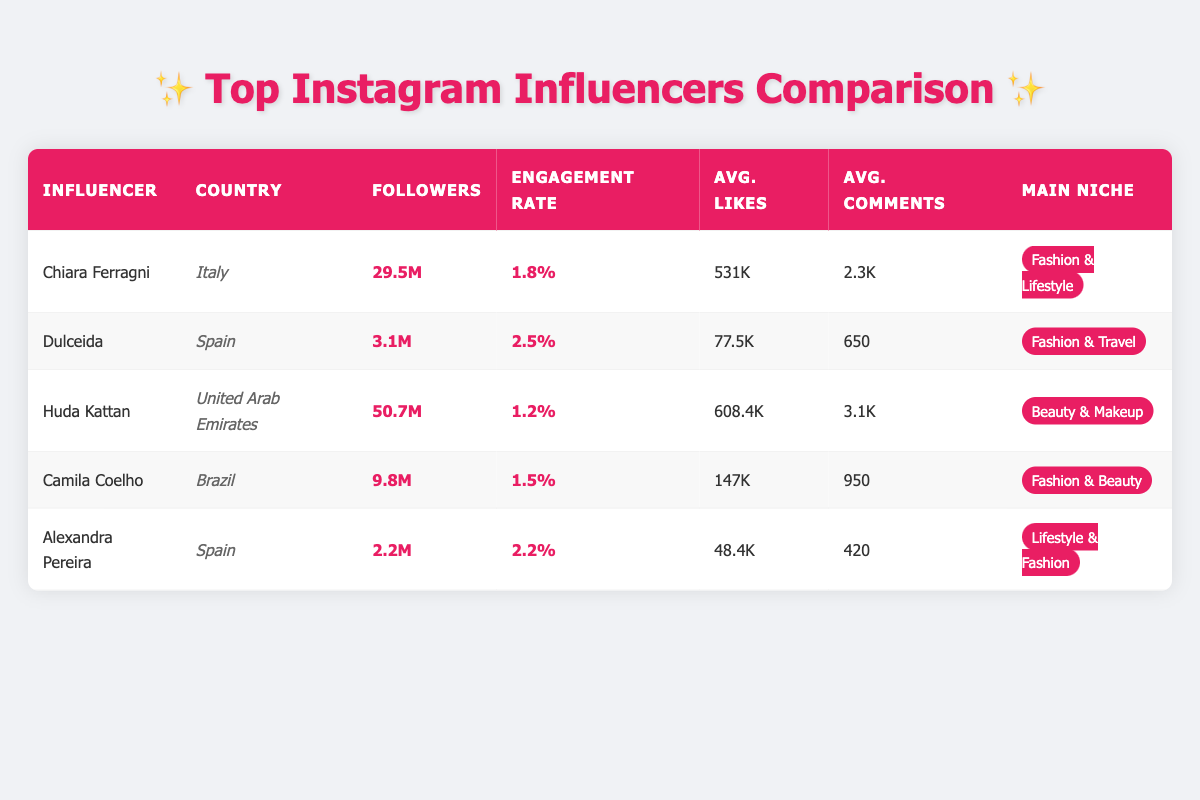What's the follower count of Chiara Ferragni? The follower count of Chiara Ferragni is stated in the table as 29.5 million.
Answer: 29.5M Which influencer has the highest engagement rate? The engagement rates are listed for each influencer in the table. By comparing the rates, Dulceida has the highest engagement rate at 2.5%.
Answer: Dulceida How many more average likes per post does Huda Kattan receive compared to Camila Coelho? Huda Kattan receives an average of 608.4K likes per post, while Camila Coelho receives 147K likes per post. The difference is 608.4K - 147K = 461.4K.
Answer: 461.4K Is the engagement rate of Alexandra Pereira higher than that of Chiara Ferragni? Alexandra Pereira has an engagement rate of 2.2%, whereas Chiara Ferragni's rate is 1.8%. Therefore, Alexandra Pereira's engagement rate is higher.
Answer: Yes What is the average number of followers among all the influencers listed? The follower counts from the table are: 29.5M, 3.1M, 50.7M, 9.8M, and 2.2M. To find the average, first convert them to the same unit (millions), which gives: 29.5, 3.1, 50.7, 9.8, and 2.2. The total is 95.3M. Dividing by 5 influencers gives an average of 19.06M.
Answer: 19.06M Which niche is most common among the top influencers listed? The table shows that Chiara Ferragni, Camila Coelho, and Dulceida focus on fashion, while Huda Kattan focuses on beauty and Alexandra Pereira focuses on lifestyle. Three influencers are related to fashion, indicating that fashion is the most common niche in this list.
Answer: Fashion 